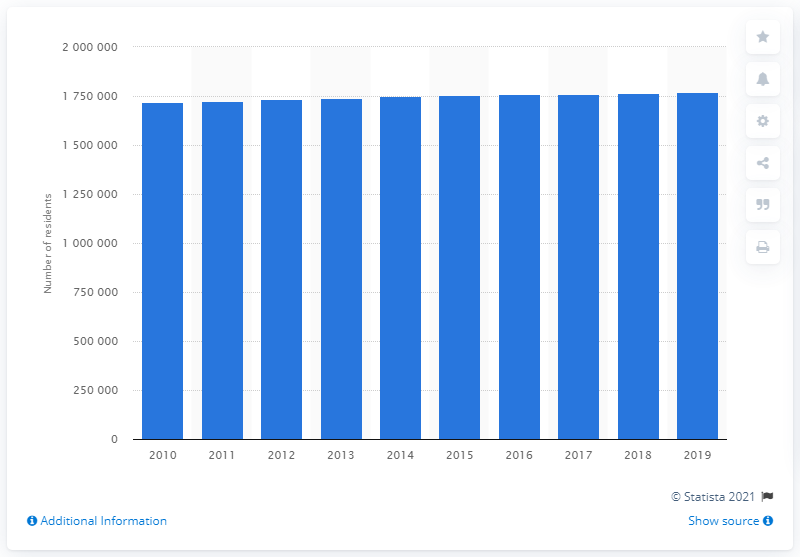Highlight a few significant elements in this photo. In 2019, the Virginia Beach-Norfolk-Newport News metropolitan area was home to 1,756,340 people. 